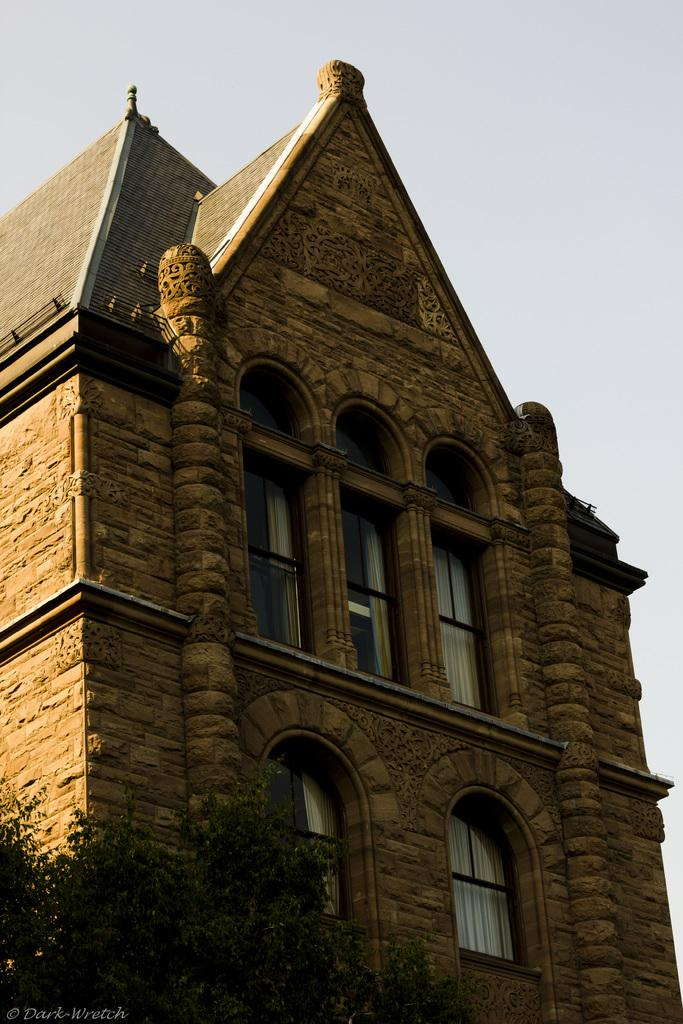What type of vegetation is located at the bottom left of the image? There are trees at the bottom left of the image. What type of structure is present in the image? There is a building in the image. What are the main features of the building? The building has walls, pillars, windows, and a roof. What is visible at the top of the image? The sky is visible at the top of the image. What type of yoke is being used for the activity in the image? There is no yoke or activity present in the image; it features a building with trees and a sky. What type of crib is visible in the image? There is no crib present in the image. 